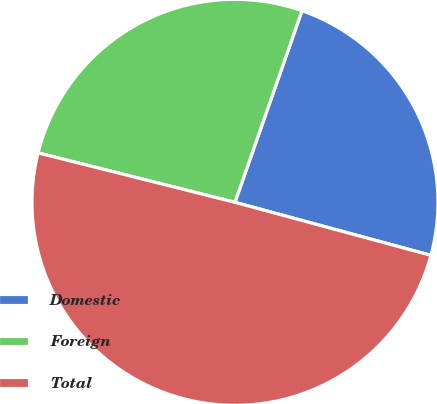Convert chart to OTSL. <chart><loc_0><loc_0><loc_500><loc_500><pie_chart><fcel>Domestic<fcel>Foreign<fcel>Total<nl><fcel>23.85%<fcel>26.44%<fcel>49.71%<nl></chart> 